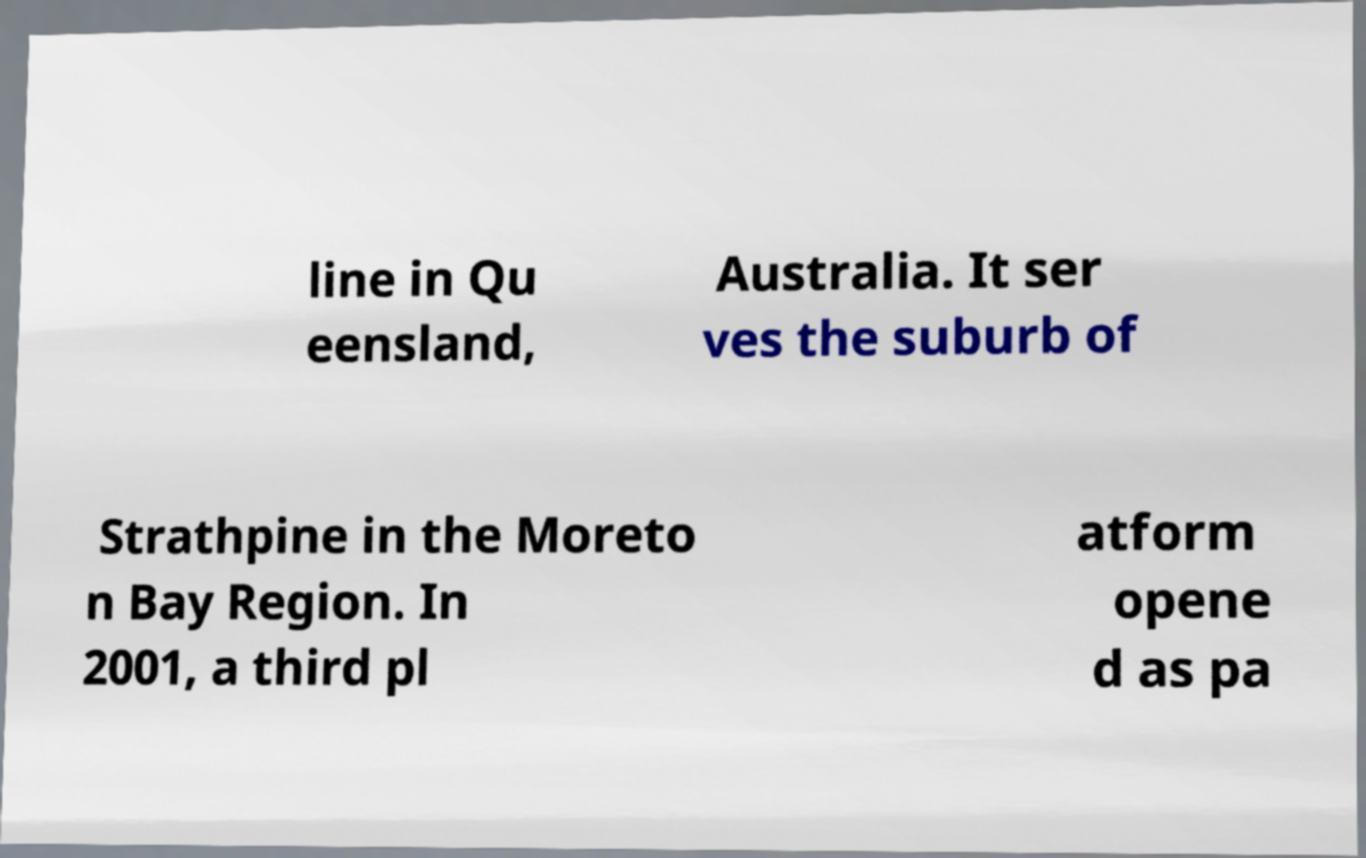Can you read and provide the text displayed in the image?This photo seems to have some interesting text. Can you extract and type it out for me? line in Qu eensland, Australia. It ser ves the suburb of Strathpine in the Moreto n Bay Region. In 2001, a third pl atform opene d as pa 